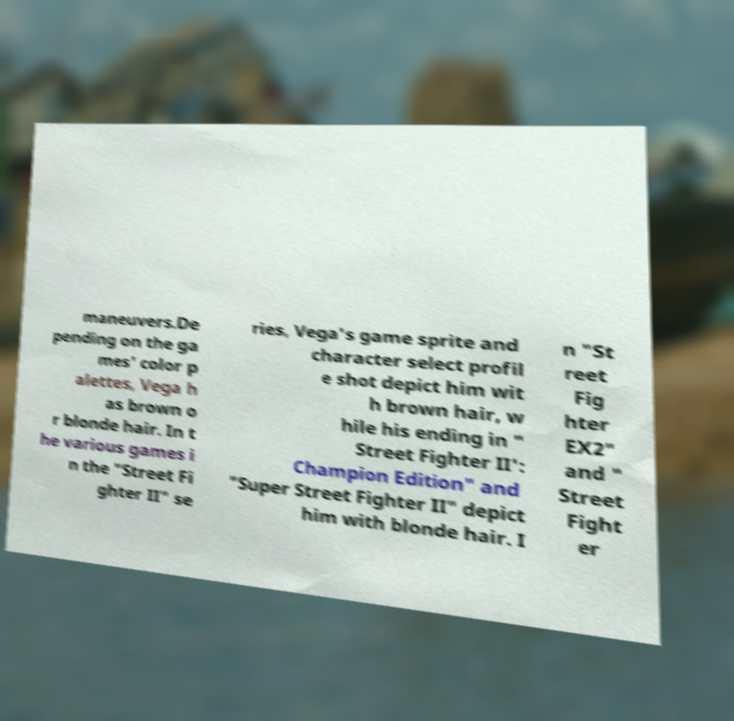Please identify and transcribe the text found in this image. maneuvers.De pending on the ga mes' color p alettes, Vega h as brown o r blonde hair. In t he various games i n the "Street Fi ghter II" se ries, Vega's game sprite and character select profil e shot depict him wit h brown hair, w hile his ending in " Street Fighter II': Champion Edition" and "Super Street Fighter II" depict him with blonde hair. I n "St reet Fig hter EX2" and " Street Fight er 